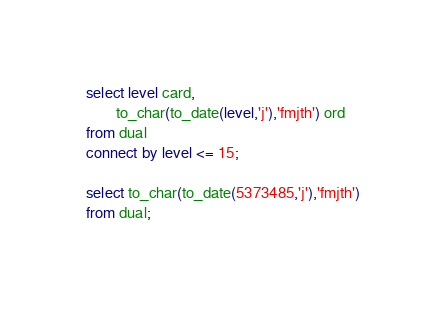Convert code to text. <code><loc_0><loc_0><loc_500><loc_500><_SQL_>select level card,
        to_char(to_date(level,'j'),'fmjth') ord
from dual
connect by level <= 15;

select to_char(to_date(5373485,'j'),'fmjth')
from dual;
</code> 